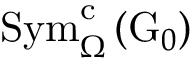<formula> <loc_0><loc_0><loc_500><loc_500>S y m _ { \Omega } ^ { c } \left ( G _ { 0 } \right )</formula> 